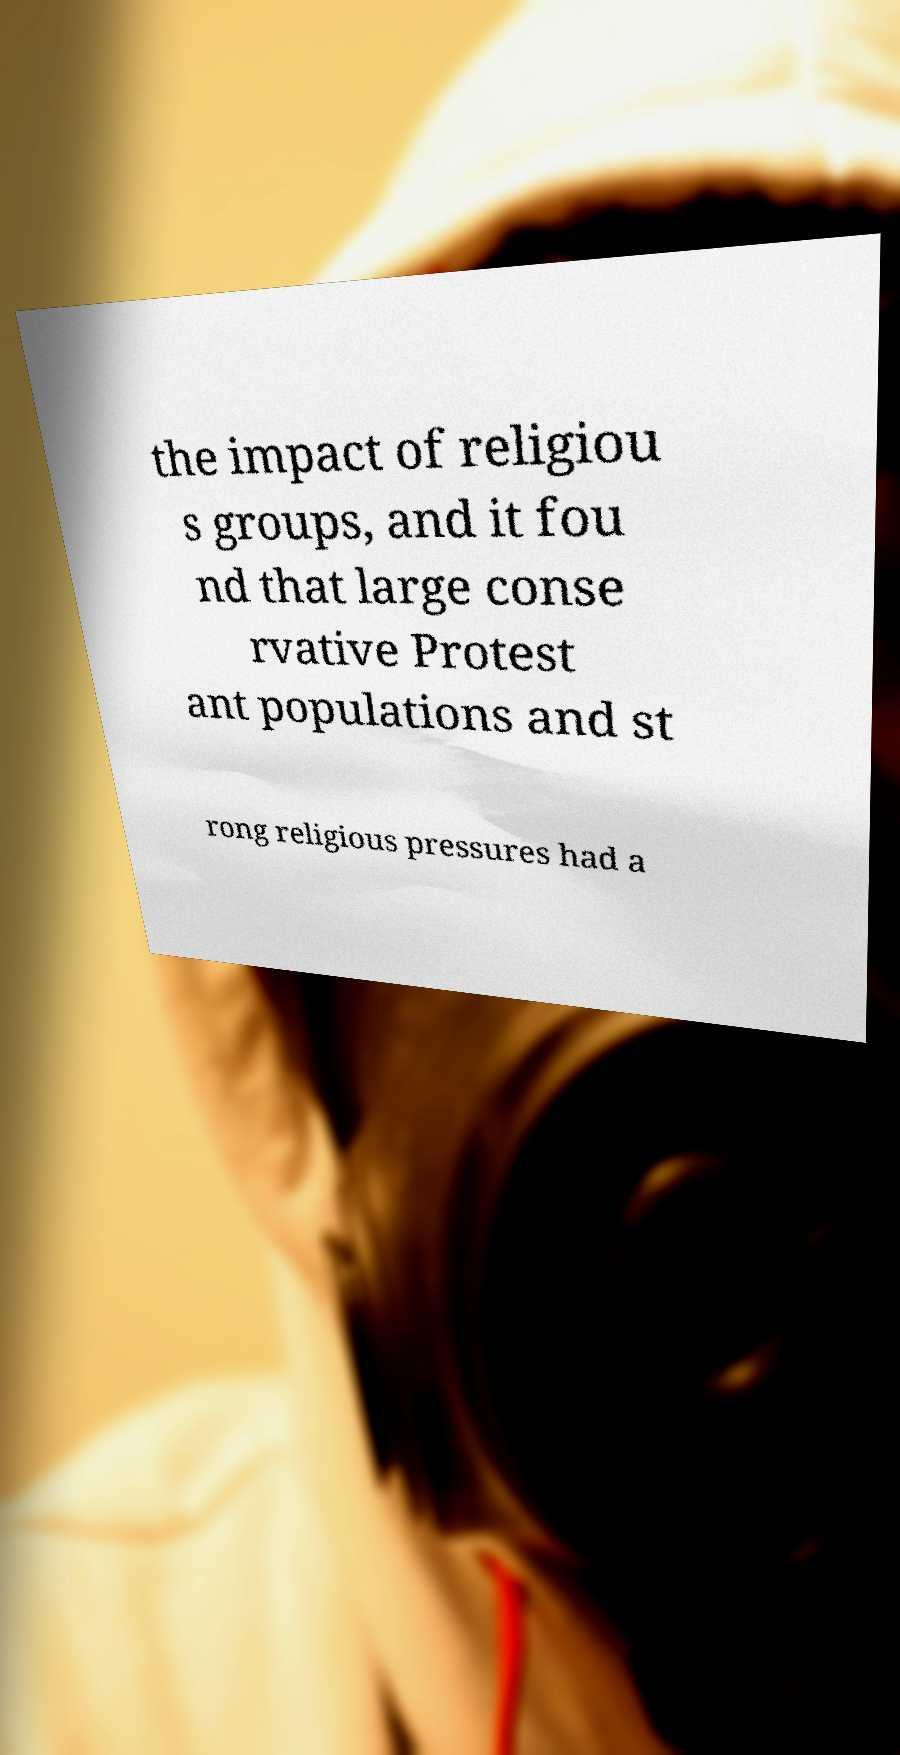Could you assist in decoding the text presented in this image and type it out clearly? the impact of religiou s groups, and it fou nd that large conse rvative Protest ant populations and st rong religious pressures had a 